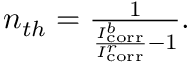Convert formula to latex. <formula><loc_0><loc_0><loc_500><loc_500>\begin{array} { r } { n _ { t h } = \frac { 1 } { \frac { I _ { c o r r } ^ { b } } { I _ { c o r r } ^ { r } } - 1 } . } \end{array}</formula> 